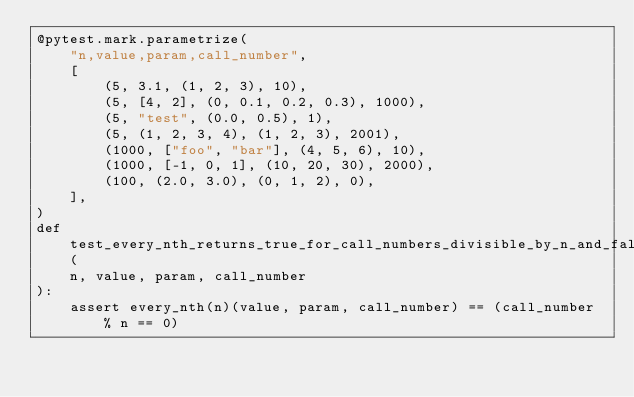Convert code to text. <code><loc_0><loc_0><loc_500><loc_500><_Python_>@pytest.mark.parametrize(
    "n,value,param,call_number",
    [
        (5, 3.1, (1, 2, 3), 10),
        (5, [4, 2], (0, 0.1, 0.2, 0.3), 1000),
        (5, "test", (0.0, 0.5), 1),
        (5, (1, 2, 3, 4), (1, 2, 3), 2001),
        (1000, ["foo", "bar"], (4, 5, 6), 10),
        (1000, [-1, 0, 1], (10, 20, 30), 2000),
        (100, (2.0, 3.0), (0, 1, 2), 0),
    ],
)
def test_every_nth_returns_true_for_call_numbers_divisible_by_n_and_false_otherwise(
    n, value, param, call_number
):
    assert every_nth(n)(value, param, call_number) == (call_number % n == 0)
</code> 